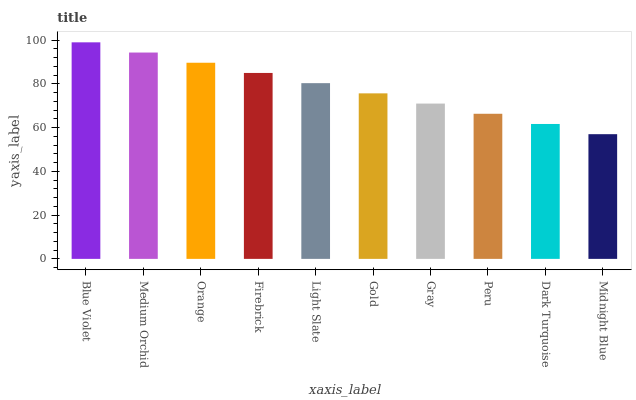Is Midnight Blue the minimum?
Answer yes or no. Yes. Is Blue Violet the maximum?
Answer yes or no. Yes. Is Medium Orchid the minimum?
Answer yes or no. No. Is Medium Orchid the maximum?
Answer yes or no. No. Is Blue Violet greater than Medium Orchid?
Answer yes or no. Yes. Is Medium Orchid less than Blue Violet?
Answer yes or no. Yes. Is Medium Orchid greater than Blue Violet?
Answer yes or no. No. Is Blue Violet less than Medium Orchid?
Answer yes or no. No. Is Light Slate the high median?
Answer yes or no. Yes. Is Gold the low median?
Answer yes or no. Yes. Is Blue Violet the high median?
Answer yes or no. No. Is Dark Turquoise the low median?
Answer yes or no. No. 